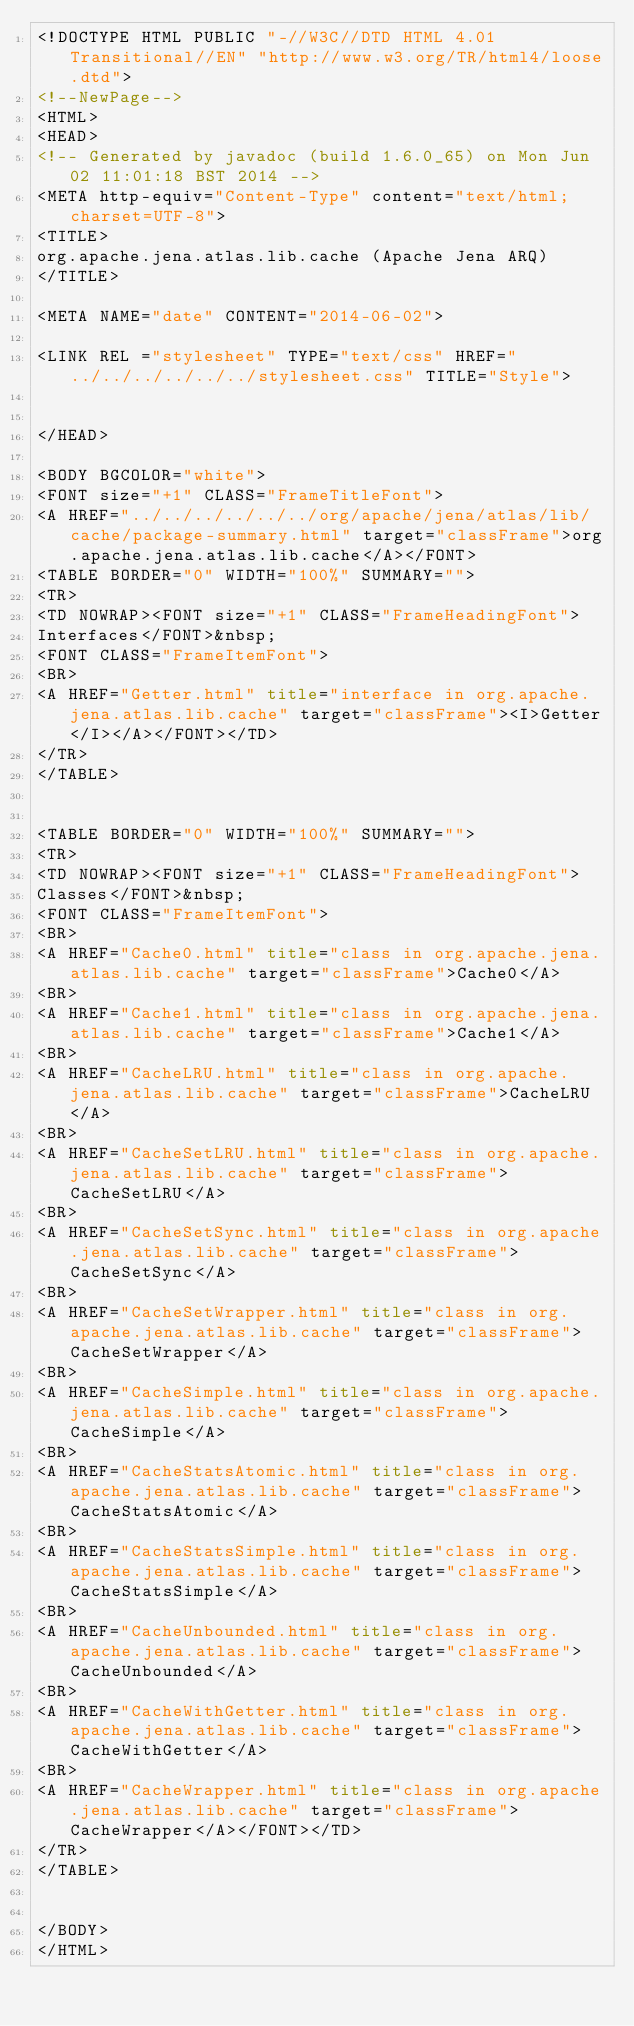Convert code to text. <code><loc_0><loc_0><loc_500><loc_500><_HTML_><!DOCTYPE HTML PUBLIC "-//W3C//DTD HTML 4.01 Transitional//EN" "http://www.w3.org/TR/html4/loose.dtd">
<!--NewPage-->
<HTML>
<HEAD>
<!-- Generated by javadoc (build 1.6.0_65) on Mon Jun 02 11:01:18 BST 2014 -->
<META http-equiv="Content-Type" content="text/html; charset=UTF-8">
<TITLE>
org.apache.jena.atlas.lib.cache (Apache Jena ARQ)
</TITLE>

<META NAME="date" CONTENT="2014-06-02">

<LINK REL ="stylesheet" TYPE="text/css" HREF="../../../../../../stylesheet.css" TITLE="Style">


</HEAD>

<BODY BGCOLOR="white">
<FONT size="+1" CLASS="FrameTitleFont">
<A HREF="../../../../../../org/apache/jena/atlas/lib/cache/package-summary.html" target="classFrame">org.apache.jena.atlas.lib.cache</A></FONT>
<TABLE BORDER="0" WIDTH="100%" SUMMARY="">
<TR>
<TD NOWRAP><FONT size="+1" CLASS="FrameHeadingFont">
Interfaces</FONT>&nbsp;
<FONT CLASS="FrameItemFont">
<BR>
<A HREF="Getter.html" title="interface in org.apache.jena.atlas.lib.cache" target="classFrame"><I>Getter</I></A></FONT></TD>
</TR>
</TABLE>


<TABLE BORDER="0" WIDTH="100%" SUMMARY="">
<TR>
<TD NOWRAP><FONT size="+1" CLASS="FrameHeadingFont">
Classes</FONT>&nbsp;
<FONT CLASS="FrameItemFont">
<BR>
<A HREF="Cache0.html" title="class in org.apache.jena.atlas.lib.cache" target="classFrame">Cache0</A>
<BR>
<A HREF="Cache1.html" title="class in org.apache.jena.atlas.lib.cache" target="classFrame">Cache1</A>
<BR>
<A HREF="CacheLRU.html" title="class in org.apache.jena.atlas.lib.cache" target="classFrame">CacheLRU</A>
<BR>
<A HREF="CacheSetLRU.html" title="class in org.apache.jena.atlas.lib.cache" target="classFrame">CacheSetLRU</A>
<BR>
<A HREF="CacheSetSync.html" title="class in org.apache.jena.atlas.lib.cache" target="classFrame">CacheSetSync</A>
<BR>
<A HREF="CacheSetWrapper.html" title="class in org.apache.jena.atlas.lib.cache" target="classFrame">CacheSetWrapper</A>
<BR>
<A HREF="CacheSimple.html" title="class in org.apache.jena.atlas.lib.cache" target="classFrame">CacheSimple</A>
<BR>
<A HREF="CacheStatsAtomic.html" title="class in org.apache.jena.atlas.lib.cache" target="classFrame">CacheStatsAtomic</A>
<BR>
<A HREF="CacheStatsSimple.html" title="class in org.apache.jena.atlas.lib.cache" target="classFrame">CacheStatsSimple</A>
<BR>
<A HREF="CacheUnbounded.html" title="class in org.apache.jena.atlas.lib.cache" target="classFrame">CacheUnbounded</A>
<BR>
<A HREF="CacheWithGetter.html" title="class in org.apache.jena.atlas.lib.cache" target="classFrame">CacheWithGetter</A>
<BR>
<A HREF="CacheWrapper.html" title="class in org.apache.jena.atlas.lib.cache" target="classFrame">CacheWrapper</A></FONT></TD>
</TR>
</TABLE>


</BODY>
</HTML>
</code> 